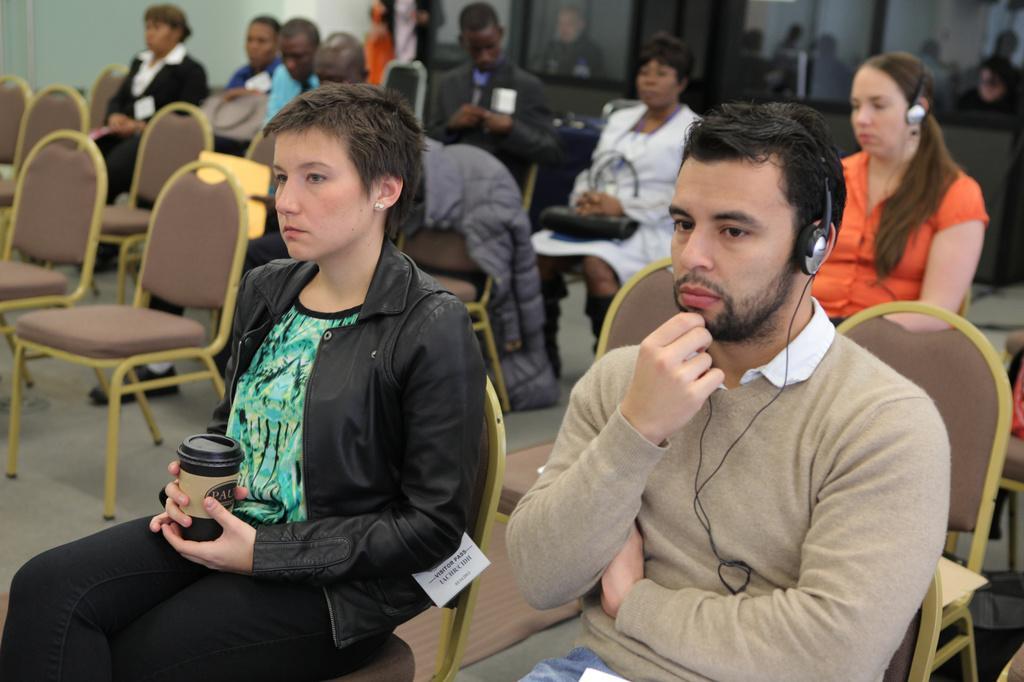Please provide a concise description of this image. In this image there are people sitting on the chairs. The man to the right is wearing a headset. The woman behind him is also wearing a headset. To the left there is a woman sitting on the chair. She is holding a glass in her hand. In the top there is a wall. In the top right there are glass windows. 